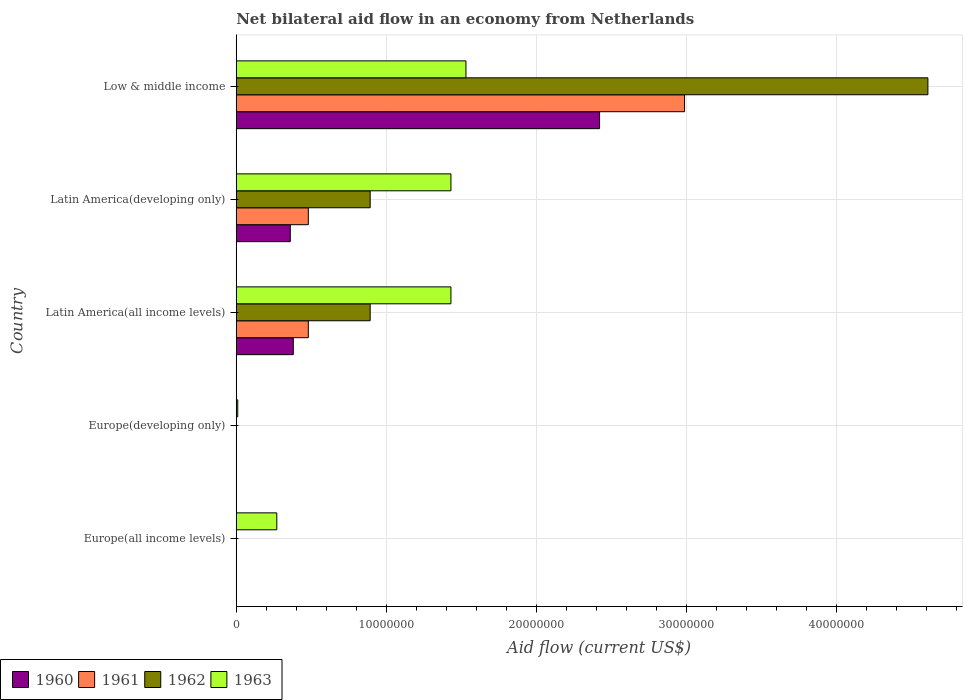How many different coloured bars are there?
Keep it short and to the point. 4. Are the number of bars per tick equal to the number of legend labels?
Your response must be concise. No. How many bars are there on the 2nd tick from the bottom?
Make the answer very short. 1. What is the label of the 2nd group of bars from the top?
Give a very brief answer. Latin America(developing only). In how many cases, is the number of bars for a given country not equal to the number of legend labels?
Ensure brevity in your answer.  2. What is the net bilateral aid flow in 1963 in Latin America(all income levels)?
Give a very brief answer. 1.43e+07. Across all countries, what is the maximum net bilateral aid flow in 1962?
Give a very brief answer. 4.61e+07. What is the total net bilateral aid flow in 1962 in the graph?
Offer a very short reply. 6.39e+07. What is the difference between the net bilateral aid flow in 1961 in Latin America(all income levels) and that in Low & middle income?
Your answer should be compact. -2.51e+07. What is the difference between the net bilateral aid flow in 1960 in Latin America(all income levels) and the net bilateral aid flow in 1962 in Europe(developing only)?
Offer a very short reply. 3.80e+06. What is the average net bilateral aid flow in 1960 per country?
Provide a short and direct response. 6.32e+06. What is the difference between the net bilateral aid flow in 1962 and net bilateral aid flow in 1960 in Latin America(all income levels)?
Provide a short and direct response. 5.12e+06. In how many countries, is the net bilateral aid flow in 1963 greater than 18000000 US$?
Make the answer very short. 0. Is the difference between the net bilateral aid flow in 1962 in Latin America(developing only) and Low & middle income greater than the difference between the net bilateral aid flow in 1960 in Latin America(developing only) and Low & middle income?
Keep it short and to the point. No. What is the difference between the highest and the second highest net bilateral aid flow in 1961?
Keep it short and to the point. 2.51e+07. What is the difference between the highest and the lowest net bilateral aid flow in 1963?
Make the answer very short. 1.52e+07. Is it the case that in every country, the sum of the net bilateral aid flow in 1961 and net bilateral aid flow in 1963 is greater than the net bilateral aid flow in 1960?
Your answer should be very brief. Yes. How many bars are there?
Provide a short and direct response. 14. What is the difference between two consecutive major ticks on the X-axis?
Provide a succinct answer. 1.00e+07. Are the values on the major ticks of X-axis written in scientific E-notation?
Your answer should be compact. No. Where does the legend appear in the graph?
Make the answer very short. Bottom left. How are the legend labels stacked?
Offer a terse response. Horizontal. What is the title of the graph?
Keep it short and to the point. Net bilateral aid flow in an economy from Netherlands. Does "1993" appear as one of the legend labels in the graph?
Provide a succinct answer. No. What is the Aid flow (current US$) in 1962 in Europe(all income levels)?
Give a very brief answer. 0. What is the Aid flow (current US$) in 1963 in Europe(all income levels)?
Make the answer very short. 2.70e+06. What is the Aid flow (current US$) of 1962 in Europe(developing only)?
Keep it short and to the point. 0. What is the Aid flow (current US$) of 1963 in Europe(developing only)?
Give a very brief answer. 1.00e+05. What is the Aid flow (current US$) of 1960 in Latin America(all income levels)?
Provide a short and direct response. 3.80e+06. What is the Aid flow (current US$) of 1961 in Latin America(all income levels)?
Make the answer very short. 4.80e+06. What is the Aid flow (current US$) of 1962 in Latin America(all income levels)?
Keep it short and to the point. 8.92e+06. What is the Aid flow (current US$) of 1963 in Latin America(all income levels)?
Ensure brevity in your answer.  1.43e+07. What is the Aid flow (current US$) in 1960 in Latin America(developing only)?
Offer a very short reply. 3.60e+06. What is the Aid flow (current US$) of 1961 in Latin America(developing only)?
Offer a terse response. 4.80e+06. What is the Aid flow (current US$) in 1962 in Latin America(developing only)?
Offer a terse response. 8.92e+06. What is the Aid flow (current US$) of 1963 in Latin America(developing only)?
Offer a very short reply. 1.43e+07. What is the Aid flow (current US$) of 1960 in Low & middle income?
Your answer should be very brief. 2.42e+07. What is the Aid flow (current US$) in 1961 in Low & middle income?
Your answer should be very brief. 2.99e+07. What is the Aid flow (current US$) of 1962 in Low & middle income?
Give a very brief answer. 4.61e+07. What is the Aid flow (current US$) of 1963 in Low & middle income?
Ensure brevity in your answer.  1.53e+07. Across all countries, what is the maximum Aid flow (current US$) of 1960?
Your answer should be compact. 2.42e+07. Across all countries, what is the maximum Aid flow (current US$) of 1961?
Make the answer very short. 2.99e+07. Across all countries, what is the maximum Aid flow (current US$) of 1962?
Offer a terse response. 4.61e+07. Across all countries, what is the maximum Aid flow (current US$) in 1963?
Provide a succinct answer. 1.53e+07. Across all countries, what is the minimum Aid flow (current US$) of 1963?
Provide a succinct answer. 1.00e+05. What is the total Aid flow (current US$) of 1960 in the graph?
Offer a very short reply. 3.16e+07. What is the total Aid flow (current US$) in 1961 in the graph?
Keep it short and to the point. 3.95e+07. What is the total Aid flow (current US$) in 1962 in the graph?
Provide a succinct answer. 6.39e+07. What is the total Aid flow (current US$) of 1963 in the graph?
Your answer should be very brief. 4.67e+07. What is the difference between the Aid flow (current US$) of 1963 in Europe(all income levels) and that in Europe(developing only)?
Make the answer very short. 2.60e+06. What is the difference between the Aid flow (current US$) in 1963 in Europe(all income levels) and that in Latin America(all income levels)?
Keep it short and to the point. -1.16e+07. What is the difference between the Aid flow (current US$) in 1963 in Europe(all income levels) and that in Latin America(developing only)?
Offer a very short reply. -1.16e+07. What is the difference between the Aid flow (current US$) of 1963 in Europe(all income levels) and that in Low & middle income?
Offer a terse response. -1.26e+07. What is the difference between the Aid flow (current US$) in 1963 in Europe(developing only) and that in Latin America(all income levels)?
Keep it short and to the point. -1.42e+07. What is the difference between the Aid flow (current US$) in 1963 in Europe(developing only) and that in Latin America(developing only)?
Ensure brevity in your answer.  -1.42e+07. What is the difference between the Aid flow (current US$) in 1963 in Europe(developing only) and that in Low & middle income?
Provide a succinct answer. -1.52e+07. What is the difference between the Aid flow (current US$) of 1960 in Latin America(all income levels) and that in Latin America(developing only)?
Ensure brevity in your answer.  2.00e+05. What is the difference between the Aid flow (current US$) in 1961 in Latin America(all income levels) and that in Latin America(developing only)?
Keep it short and to the point. 0. What is the difference between the Aid flow (current US$) in 1963 in Latin America(all income levels) and that in Latin America(developing only)?
Make the answer very short. 0. What is the difference between the Aid flow (current US$) in 1960 in Latin America(all income levels) and that in Low & middle income?
Give a very brief answer. -2.04e+07. What is the difference between the Aid flow (current US$) in 1961 in Latin America(all income levels) and that in Low & middle income?
Give a very brief answer. -2.51e+07. What is the difference between the Aid flow (current US$) of 1962 in Latin America(all income levels) and that in Low & middle income?
Ensure brevity in your answer.  -3.72e+07. What is the difference between the Aid flow (current US$) of 1960 in Latin America(developing only) and that in Low & middle income?
Provide a succinct answer. -2.06e+07. What is the difference between the Aid flow (current US$) in 1961 in Latin America(developing only) and that in Low & middle income?
Provide a succinct answer. -2.51e+07. What is the difference between the Aid flow (current US$) in 1962 in Latin America(developing only) and that in Low & middle income?
Keep it short and to the point. -3.72e+07. What is the difference between the Aid flow (current US$) in 1963 in Latin America(developing only) and that in Low & middle income?
Ensure brevity in your answer.  -1.00e+06. What is the difference between the Aid flow (current US$) in 1960 in Latin America(all income levels) and the Aid flow (current US$) in 1961 in Latin America(developing only)?
Keep it short and to the point. -1.00e+06. What is the difference between the Aid flow (current US$) of 1960 in Latin America(all income levels) and the Aid flow (current US$) of 1962 in Latin America(developing only)?
Your answer should be compact. -5.12e+06. What is the difference between the Aid flow (current US$) in 1960 in Latin America(all income levels) and the Aid flow (current US$) in 1963 in Latin America(developing only)?
Provide a short and direct response. -1.05e+07. What is the difference between the Aid flow (current US$) in 1961 in Latin America(all income levels) and the Aid flow (current US$) in 1962 in Latin America(developing only)?
Provide a succinct answer. -4.12e+06. What is the difference between the Aid flow (current US$) in 1961 in Latin America(all income levels) and the Aid flow (current US$) in 1963 in Latin America(developing only)?
Keep it short and to the point. -9.50e+06. What is the difference between the Aid flow (current US$) in 1962 in Latin America(all income levels) and the Aid flow (current US$) in 1963 in Latin America(developing only)?
Your answer should be compact. -5.38e+06. What is the difference between the Aid flow (current US$) in 1960 in Latin America(all income levels) and the Aid flow (current US$) in 1961 in Low & middle income?
Your response must be concise. -2.61e+07. What is the difference between the Aid flow (current US$) of 1960 in Latin America(all income levels) and the Aid flow (current US$) of 1962 in Low & middle income?
Your answer should be compact. -4.23e+07. What is the difference between the Aid flow (current US$) of 1960 in Latin America(all income levels) and the Aid flow (current US$) of 1963 in Low & middle income?
Ensure brevity in your answer.  -1.15e+07. What is the difference between the Aid flow (current US$) of 1961 in Latin America(all income levels) and the Aid flow (current US$) of 1962 in Low & middle income?
Ensure brevity in your answer.  -4.13e+07. What is the difference between the Aid flow (current US$) in 1961 in Latin America(all income levels) and the Aid flow (current US$) in 1963 in Low & middle income?
Make the answer very short. -1.05e+07. What is the difference between the Aid flow (current US$) of 1962 in Latin America(all income levels) and the Aid flow (current US$) of 1963 in Low & middle income?
Your answer should be very brief. -6.38e+06. What is the difference between the Aid flow (current US$) in 1960 in Latin America(developing only) and the Aid flow (current US$) in 1961 in Low & middle income?
Offer a terse response. -2.63e+07. What is the difference between the Aid flow (current US$) of 1960 in Latin America(developing only) and the Aid flow (current US$) of 1962 in Low & middle income?
Your response must be concise. -4.25e+07. What is the difference between the Aid flow (current US$) in 1960 in Latin America(developing only) and the Aid flow (current US$) in 1963 in Low & middle income?
Provide a succinct answer. -1.17e+07. What is the difference between the Aid flow (current US$) in 1961 in Latin America(developing only) and the Aid flow (current US$) in 1962 in Low & middle income?
Offer a terse response. -4.13e+07. What is the difference between the Aid flow (current US$) of 1961 in Latin America(developing only) and the Aid flow (current US$) of 1963 in Low & middle income?
Provide a short and direct response. -1.05e+07. What is the difference between the Aid flow (current US$) of 1962 in Latin America(developing only) and the Aid flow (current US$) of 1963 in Low & middle income?
Your response must be concise. -6.38e+06. What is the average Aid flow (current US$) of 1960 per country?
Your answer should be very brief. 6.32e+06. What is the average Aid flow (current US$) in 1961 per country?
Offer a very short reply. 7.89e+06. What is the average Aid flow (current US$) of 1962 per country?
Keep it short and to the point. 1.28e+07. What is the average Aid flow (current US$) of 1963 per country?
Give a very brief answer. 9.34e+06. What is the difference between the Aid flow (current US$) of 1960 and Aid flow (current US$) of 1962 in Latin America(all income levels)?
Offer a terse response. -5.12e+06. What is the difference between the Aid flow (current US$) of 1960 and Aid flow (current US$) of 1963 in Latin America(all income levels)?
Offer a terse response. -1.05e+07. What is the difference between the Aid flow (current US$) of 1961 and Aid flow (current US$) of 1962 in Latin America(all income levels)?
Your response must be concise. -4.12e+06. What is the difference between the Aid flow (current US$) in 1961 and Aid flow (current US$) in 1963 in Latin America(all income levels)?
Your response must be concise. -9.50e+06. What is the difference between the Aid flow (current US$) of 1962 and Aid flow (current US$) of 1963 in Latin America(all income levels)?
Give a very brief answer. -5.38e+06. What is the difference between the Aid flow (current US$) in 1960 and Aid flow (current US$) in 1961 in Latin America(developing only)?
Offer a terse response. -1.20e+06. What is the difference between the Aid flow (current US$) in 1960 and Aid flow (current US$) in 1962 in Latin America(developing only)?
Offer a very short reply. -5.32e+06. What is the difference between the Aid flow (current US$) in 1960 and Aid flow (current US$) in 1963 in Latin America(developing only)?
Make the answer very short. -1.07e+07. What is the difference between the Aid flow (current US$) of 1961 and Aid flow (current US$) of 1962 in Latin America(developing only)?
Offer a terse response. -4.12e+06. What is the difference between the Aid flow (current US$) of 1961 and Aid flow (current US$) of 1963 in Latin America(developing only)?
Provide a short and direct response. -9.50e+06. What is the difference between the Aid flow (current US$) of 1962 and Aid flow (current US$) of 1963 in Latin America(developing only)?
Your response must be concise. -5.38e+06. What is the difference between the Aid flow (current US$) in 1960 and Aid flow (current US$) in 1961 in Low & middle income?
Provide a succinct answer. -5.66e+06. What is the difference between the Aid flow (current US$) in 1960 and Aid flow (current US$) in 1962 in Low & middle income?
Your answer should be very brief. -2.19e+07. What is the difference between the Aid flow (current US$) of 1960 and Aid flow (current US$) of 1963 in Low & middle income?
Ensure brevity in your answer.  8.90e+06. What is the difference between the Aid flow (current US$) of 1961 and Aid flow (current US$) of 1962 in Low & middle income?
Your answer should be compact. -1.62e+07. What is the difference between the Aid flow (current US$) in 1961 and Aid flow (current US$) in 1963 in Low & middle income?
Offer a very short reply. 1.46e+07. What is the difference between the Aid flow (current US$) of 1962 and Aid flow (current US$) of 1963 in Low & middle income?
Keep it short and to the point. 3.08e+07. What is the ratio of the Aid flow (current US$) of 1963 in Europe(all income levels) to that in Latin America(all income levels)?
Provide a succinct answer. 0.19. What is the ratio of the Aid flow (current US$) of 1963 in Europe(all income levels) to that in Latin America(developing only)?
Keep it short and to the point. 0.19. What is the ratio of the Aid flow (current US$) of 1963 in Europe(all income levels) to that in Low & middle income?
Your answer should be very brief. 0.18. What is the ratio of the Aid flow (current US$) in 1963 in Europe(developing only) to that in Latin America(all income levels)?
Provide a short and direct response. 0.01. What is the ratio of the Aid flow (current US$) in 1963 in Europe(developing only) to that in Latin America(developing only)?
Give a very brief answer. 0.01. What is the ratio of the Aid flow (current US$) of 1963 in Europe(developing only) to that in Low & middle income?
Make the answer very short. 0.01. What is the ratio of the Aid flow (current US$) of 1960 in Latin America(all income levels) to that in Latin America(developing only)?
Ensure brevity in your answer.  1.06. What is the ratio of the Aid flow (current US$) in 1961 in Latin America(all income levels) to that in Latin America(developing only)?
Provide a short and direct response. 1. What is the ratio of the Aid flow (current US$) of 1962 in Latin America(all income levels) to that in Latin America(developing only)?
Ensure brevity in your answer.  1. What is the ratio of the Aid flow (current US$) in 1960 in Latin America(all income levels) to that in Low & middle income?
Offer a terse response. 0.16. What is the ratio of the Aid flow (current US$) of 1961 in Latin America(all income levels) to that in Low & middle income?
Provide a short and direct response. 0.16. What is the ratio of the Aid flow (current US$) in 1962 in Latin America(all income levels) to that in Low & middle income?
Ensure brevity in your answer.  0.19. What is the ratio of the Aid flow (current US$) in 1963 in Latin America(all income levels) to that in Low & middle income?
Your answer should be compact. 0.93. What is the ratio of the Aid flow (current US$) in 1960 in Latin America(developing only) to that in Low & middle income?
Your answer should be compact. 0.15. What is the ratio of the Aid flow (current US$) of 1961 in Latin America(developing only) to that in Low & middle income?
Give a very brief answer. 0.16. What is the ratio of the Aid flow (current US$) in 1962 in Latin America(developing only) to that in Low & middle income?
Keep it short and to the point. 0.19. What is the ratio of the Aid flow (current US$) of 1963 in Latin America(developing only) to that in Low & middle income?
Provide a succinct answer. 0.93. What is the difference between the highest and the second highest Aid flow (current US$) of 1960?
Keep it short and to the point. 2.04e+07. What is the difference between the highest and the second highest Aid flow (current US$) of 1961?
Provide a short and direct response. 2.51e+07. What is the difference between the highest and the second highest Aid flow (current US$) of 1962?
Provide a succinct answer. 3.72e+07. What is the difference between the highest and the second highest Aid flow (current US$) in 1963?
Make the answer very short. 1.00e+06. What is the difference between the highest and the lowest Aid flow (current US$) in 1960?
Provide a succinct answer. 2.42e+07. What is the difference between the highest and the lowest Aid flow (current US$) of 1961?
Offer a terse response. 2.99e+07. What is the difference between the highest and the lowest Aid flow (current US$) of 1962?
Provide a succinct answer. 4.61e+07. What is the difference between the highest and the lowest Aid flow (current US$) in 1963?
Ensure brevity in your answer.  1.52e+07. 